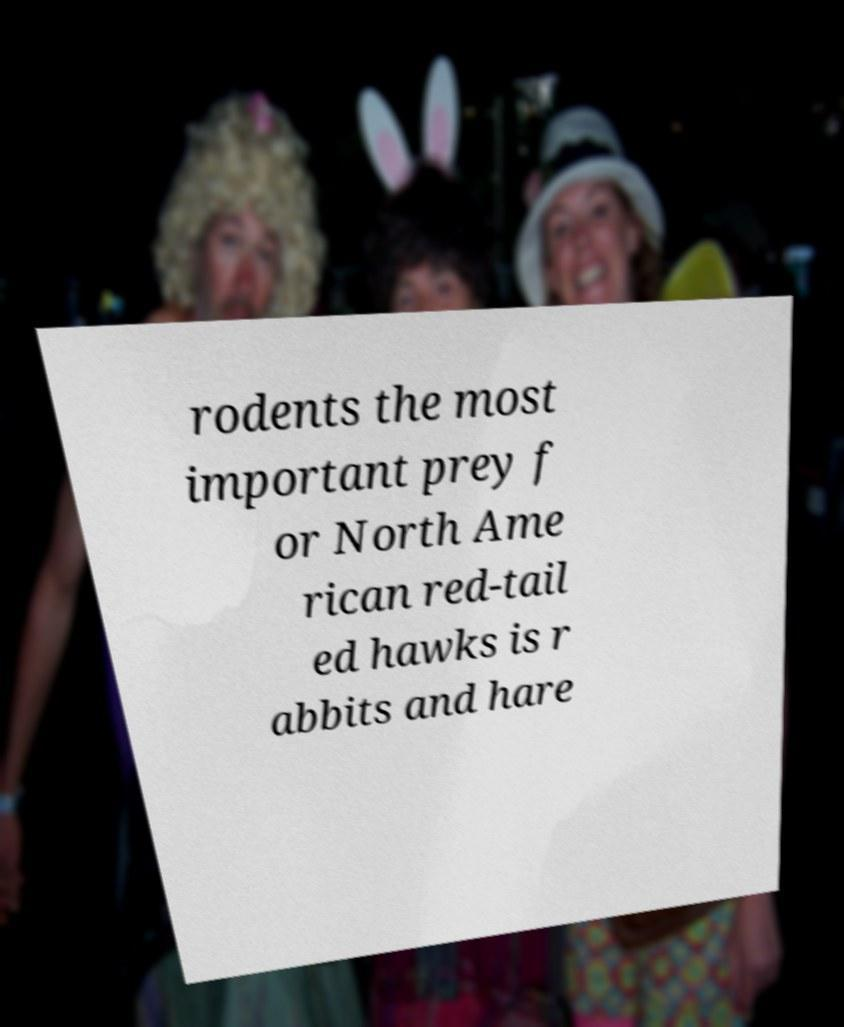What messages or text are displayed in this image? I need them in a readable, typed format. rodents the most important prey f or North Ame rican red-tail ed hawks is r abbits and hare 